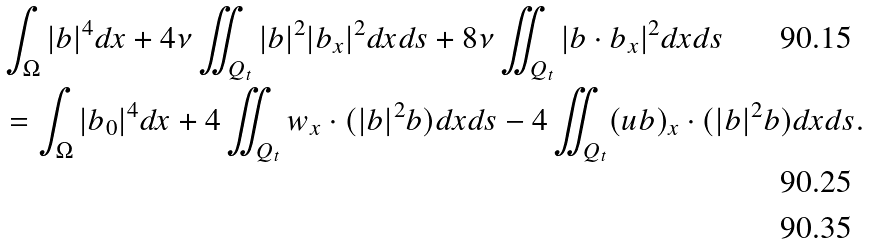Convert formula to latex. <formula><loc_0><loc_0><loc_500><loc_500>& \int _ { \Omega } | b | ^ { 4 } d x + 4 \nu \iint _ { Q _ { t } } | b | ^ { 2 } | b _ { x } | ^ { 2 } d x d s + 8 \nu \iint _ { Q _ { t } } | b \cdot b _ { x } | ^ { 2 } d x d s \\ & = \int _ { \Omega } | b _ { 0 } | ^ { 4 } d x + 4 \iint _ { Q _ { t } } w _ { x } \cdot ( | b | ^ { 2 } b ) d x d s - 4 \iint _ { Q _ { t } } ( u b ) _ { x } \cdot ( | b | ^ { 2 } b ) d x d s . \\</formula> 